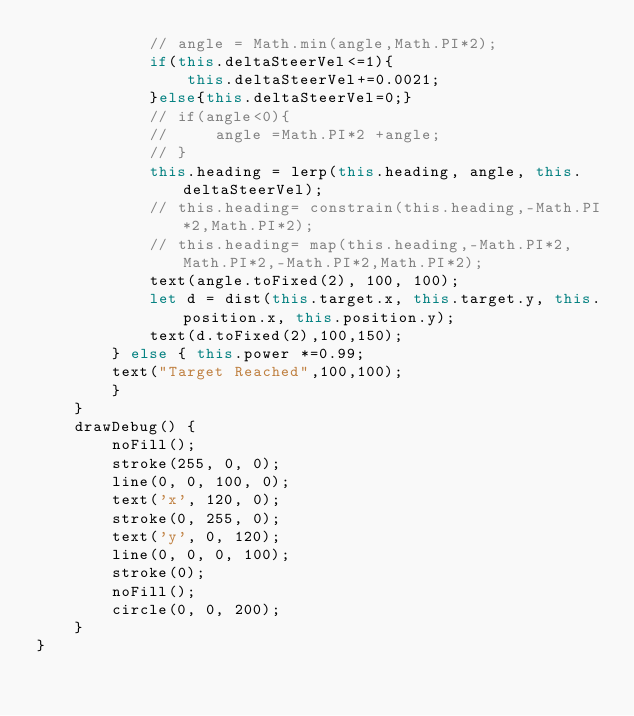Convert code to text. <code><loc_0><loc_0><loc_500><loc_500><_JavaScript_>            // angle = Math.min(angle,Math.PI*2);
            if(this.deltaSteerVel<=1){
                this.deltaSteerVel+=0.0021;
            }else{this.deltaSteerVel=0;}
            // if(angle<0){
            //     angle =Math.PI*2 +angle;
            // }
            this.heading = lerp(this.heading, angle, this.deltaSteerVel);
            // this.heading= constrain(this.heading,-Math.PI*2,Math.PI*2);
            // this.heading= map(this.heading,-Math.PI*2,Math.PI*2,-Math.PI*2,Math.PI*2);
            text(angle.toFixed(2), 100, 100);
            let d = dist(this.target.x, this.target.y, this.position.x, this.position.y);
            text(d.toFixed(2),100,150);
        } else { this.power *=0.99; 
        text("Target Reached",100,100);
        }
    }
    drawDebug() {
        noFill();
        stroke(255, 0, 0);
        line(0, 0, 100, 0);
        text('x', 120, 0);
        stroke(0, 255, 0);
        text('y', 0, 120);
        line(0, 0, 0, 100);
        stroke(0);
        noFill();
        circle(0, 0, 200);
    }
}</code> 